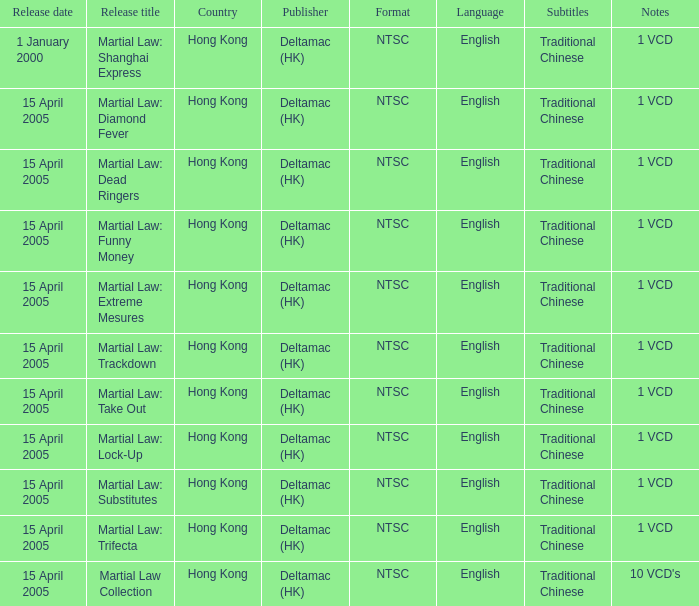Which country had a release of 1 VCD titled Martial Law: Substitutes? Hong Kong. 